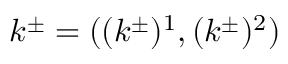Convert formula to latex. <formula><loc_0><loc_0><loc_500><loc_500>k ^ { \pm } = ( ( k ^ { \pm } ) ^ { 1 } , ( k ^ { \pm } ) ^ { 2 } )</formula> 